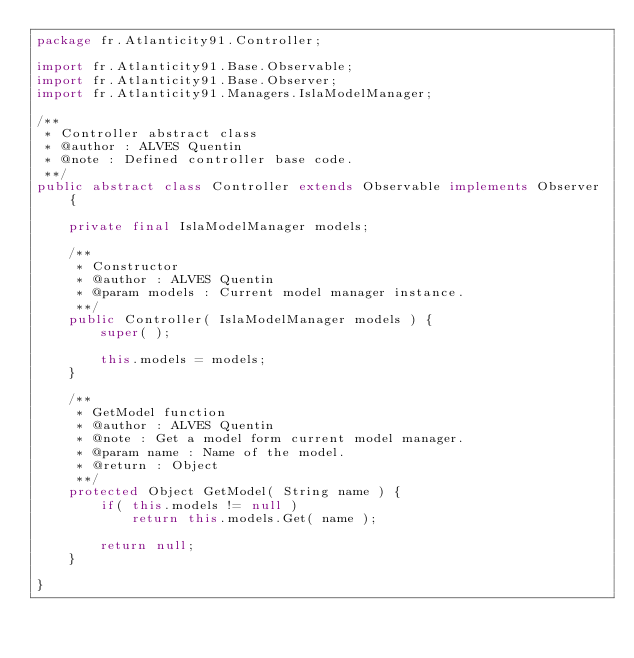Convert code to text. <code><loc_0><loc_0><loc_500><loc_500><_Java_>package fr.Atlanticity91.Controller;

import fr.Atlanticity91.Base.Observable;
import fr.Atlanticity91.Base.Observer;
import fr.Atlanticity91.Managers.IslaModelManager;

/**
 * Controller abstract class
 * @author : ALVES Quentin
 * @note : Defined controller base code.
 **/
public abstract class Controller extends Observable implements Observer {

    private final IslaModelManager models;

    /**
     * Constructor
     * @author : ALVES Quentin
     * @param models : Current model manager instance.
     **/
    public Controller( IslaModelManager models ) {
        super( );

        this.models = models;
    }

    /**
     * GetModel function
     * @author : ALVES Quentin
     * @note : Get a model form current model manager.
     * @param name : Name of the model.
     * @return : Object
     **/
    protected Object GetModel( String name ) {
        if( this.models != null )
            return this.models.Get( name );

        return null;
    }

}
</code> 